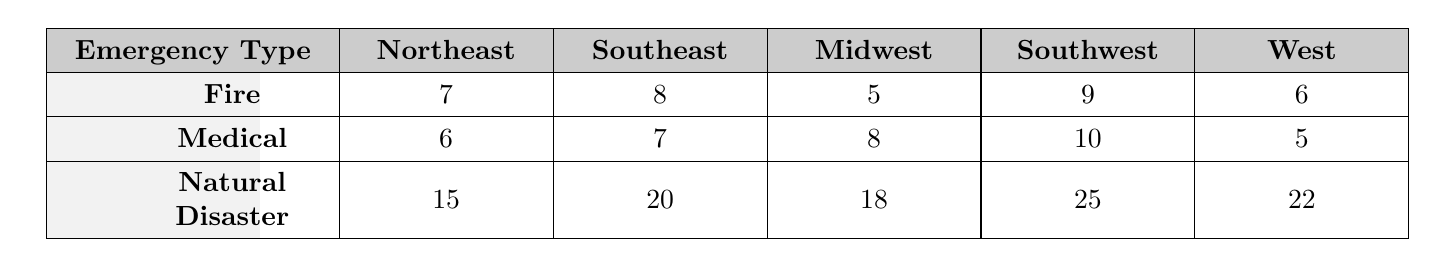What is the response time for Fire emergencies in the Midwest region? The table shows that the response time for Fire emergencies in the Midwest region is 5 minutes.
Answer: 5 minutes Which region has the longest response time for Natural Disasters? According to the table, the Southwest region has the longest response time for Natural Disasters at 25 minutes.
Answer: 25 minutes What is the average response time for Medical emergencies across all regions? The response times for Medical emergencies are 6, 7, 8, 10, and 5 minutes. The sum is 36 minutes and there are 5 regions, thus, the average is 36/5 = 7.2 minutes.
Answer: 7.2 minutes Is the response time for Medical emergencies in the West the quickest? Comparing the Medical response times in all regions, the West has a response time of 5 minutes, which is lower than the other regions. Therefore, the statement is true.
Answer: True Which emergency type has the highest response time on average across all regions? The average response times for Fire, Medical, and Natural Disaster emergencies are calculated as follows: Fire average is (7 + 8 + 5 + 9 + 6)/5 = 7, Medical average is (6 + 7 + 8 + 10 + 5)/5 = 7.2, and Natural Disaster average is (15 + 20 + 18 + 25 + 22)/5 = 20. The highest is for Natural Disasters at 20 minutes.
Answer: Natural Disaster What is the difference in response time for Fire emergencies between the Northeast and the Southwest? The response time for Fire in the Northeast is 7 minutes and in the Southwest is 9 minutes. The difference is 9 - 7 = 2 minutes.
Answer: 2 minutes Which region has a quicker response time for Medical emergencies: Southeast or Midwest? The response time for Medical emergencies in the Southeast is 7 minutes while in the Midwest it is 8 minutes. Therefore, the Southeast has a quicker response time.
Answer: Southeast How many regions have a response time for Natural Disasters less than 20 minutes? The regions with Natural Disaster response times are Northeast (15), Southeast (20), Midwest (18), Southwest (25), and West (22). Only the Northeast and Midwest have response times less than 20 minutes, totaling 2 regions.
Answer: 2 regions What is the total response time for Fire emergencies across all regions? The total response time for Fire emergencies is calculated by summing the response times: 7 + 8 + 5 + 9 + 6 = 35 minutes.
Answer: 35 minutes 